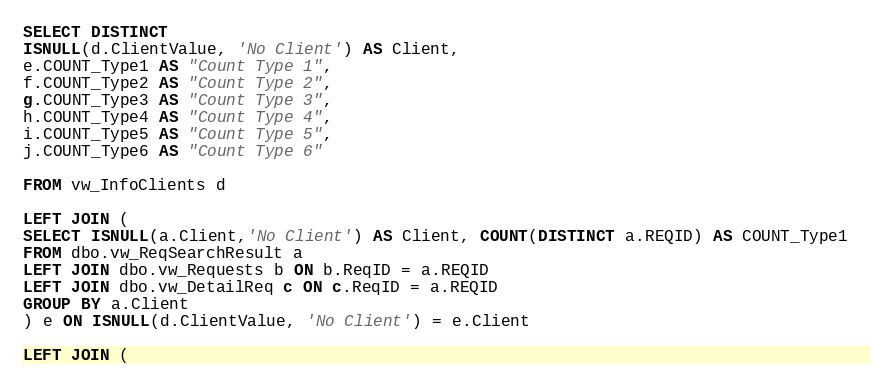<code> <loc_0><loc_0><loc_500><loc_500><_SQL_>SELECT DISTINCT 
ISNULL(d.ClientValue, 'No Client') AS Client,
e.COUNT_Type1 AS "Count Type 1",
f.COUNT_Type2 AS "Count Type 2",
g.COUNT_Type3 AS "Count Type 3",
h.COUNT_Type4 AS "Count Type 4",
i.COUNT_Type5 AS "Count Type 5",
j.COUNT_Type6 AS "Count Type 6"

FROM vw_InfoClients d

LEFT JOIN (
SELECT ISNULL(a.Client,'No Client') AS Client, COUNT(DISTINCT a.REQID) AS COUNT_Type1
FROM dbo.vw_ReqSearchResult a
LEFT JOIN dbo.vw_Requests b ON b.ReqID = a.REQID
LEFT JOIN dbo.vw_DetailReq c ON c.ReqID = a.REQID
GROUP BY a.Client
) e ON ISNULL(d.ClientValue, 'No Client') = e.Client 

LEFT JOIN (</code> 